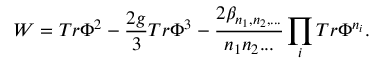Convert formula to latex. <formula><loc_0><loc_0><loc_500><loc_500>W = T r \Phi ^ { 2 } - \frac { 2 g } { 3 } T r \Phi ^ { 3 } - \frac { 2 \beta _ { n _ { 1 } , n _ { 2 } , \dots } } { n _ { 1 } n _ { 2 } \dots } \prod _ { i } T r \Phi ^ { n _ { i } } .</formula> 